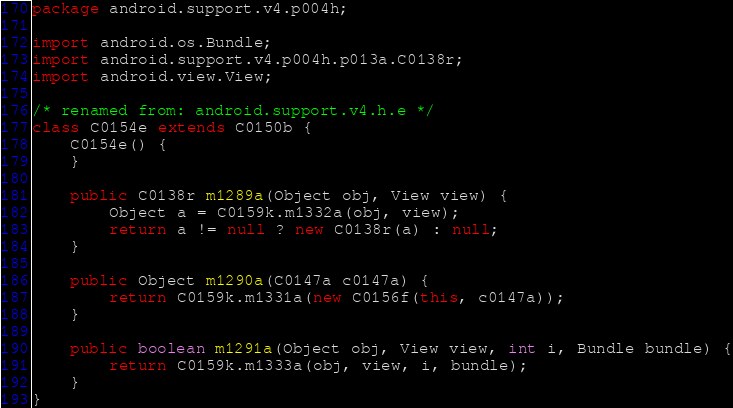Convert code to text. <code><loc_0><loc_0><loc_500><loc_500><_Java_>package android.support.v4.p004h;

import android.os.Bundle;
import android.support.v4.p004h.p013a.C0138r;
import android.view.View;

/* renamed from: android.support.v4.h.e */
class C0154e extends C0150b {
    C0154e() {
    }

    public C0138r m1289a(Object obj, View view) {
        Object a = C0159k.m1332a(obj, view);
        return a != null ? new C0138r(a) : null;
    }

    public Object m1290a(C0147a c0147a) {
        return C0159k.m1331a(new C0156f(this, c0147a));
    }

    public boolean m1291a(Object obj, View view, int i, Bundle bundle) {
        return C0159k.m1333a(obj, view, i, bundle);
    }
}
</code> 